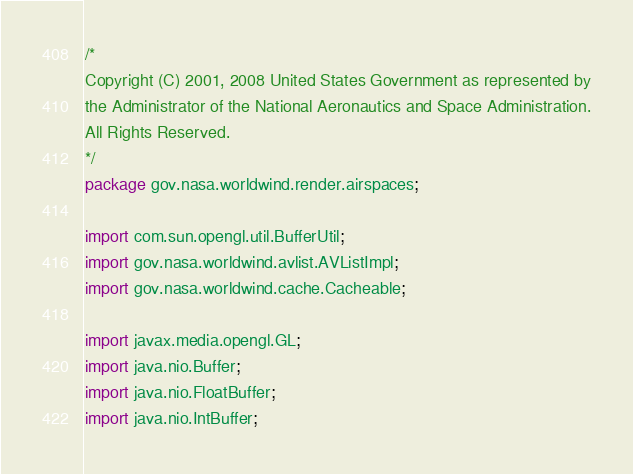<code> <loc_0><loc_0><loc_500><loc_500><_Java_>/*
Copyright (C) 2001, 2008 United States Government as represented by
the Administrator of the National Aeronautics and Space Administration.
All Rights Reserved.
*/
package gov.nasa.worldwind.render.airspaces;

import com.sun.opengl.util.BufferUtil;
import gov.nasa.worldwind.avlist.AVListImpl;
import gov.nasa.worldwind.cache.Cacheable;

import javax.media.opengl.GL;
import java.nio.Buffer;
import java.nio.FloatBuffer;
import java.nio.IntBuffer;</code> 